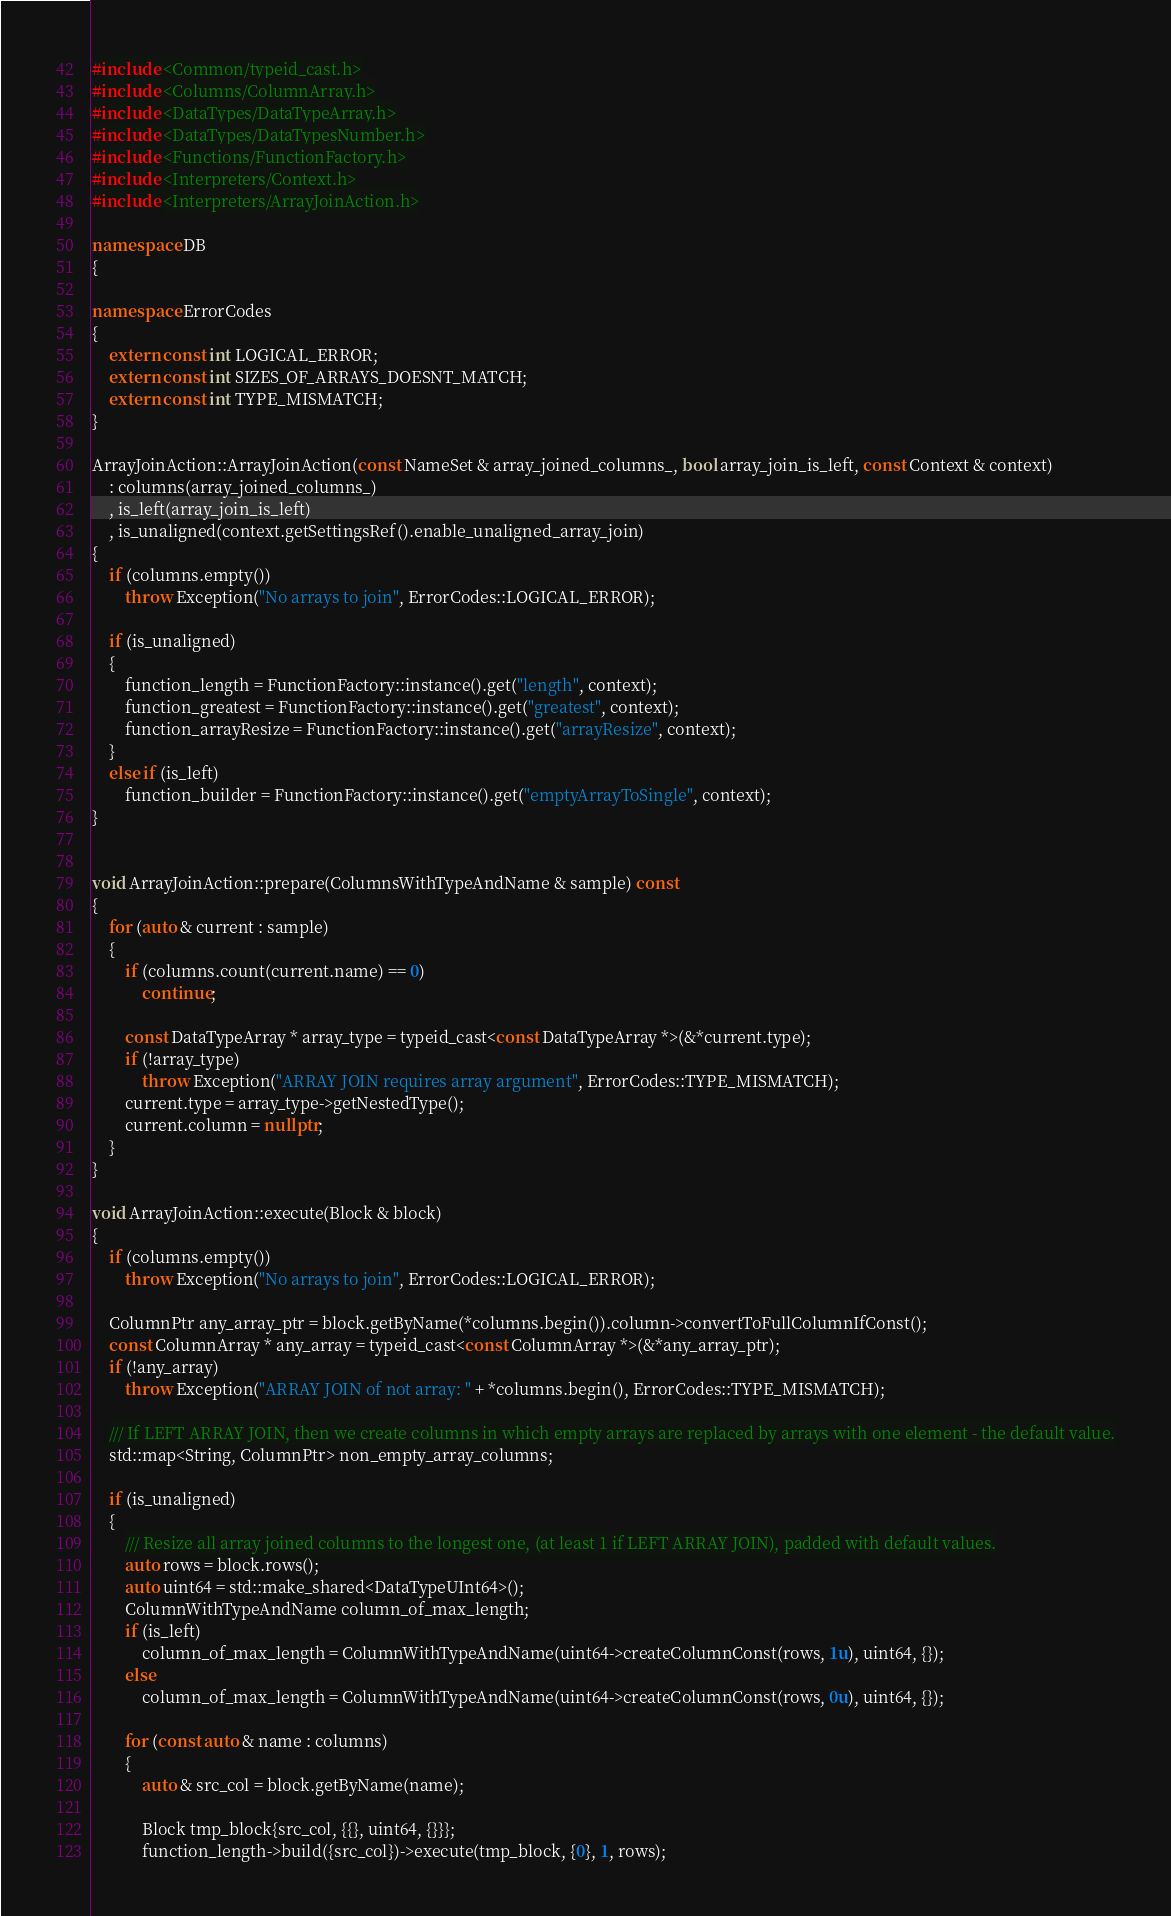Convert code to text. <code><loc_0><loc_0><loc_500><loc_500><_C++_>#include <Common/typeid_cast.h>
#include <Columns/ColumnArray.h>
#include <DataTypes/DataTypeArray.h>
#include <DataTypes/DataTypesNumber.h>
#include <Functions/FunctionFactory.h>
#include <Interpreters/Context.h>
#include <Interpreters/ArrayJoinAction.h>

namespace DB
{

namespace ErrorCodes
{
    extern const int LOGICAL_ERROR;
    extern const int SIZES_OF_ARRAYS_DOESNT_MATCH;
    extern const int TYPE_MISMATCH;
}

ArrayJoinAction::ArrayJoinAction(const NameSet & array_joined_columns_, bool array_join_is_left, const Context & context)
    : columns(array_joined_columns_)
    , is_left(array_join_is_left)
    , is_unaligned(context.getSettingsRef().enable_unaligned_array_join)
{
    if (columns.empty())
        throw Exception("No arrays to join", ErrorCodes::LOGICAL_ERROR);

    if (is_unaligned)
    {
        function_length = FunctionFactory::instance().get("length", context);
        function_greatest = FunctionFactory::instance().get("greatest", context);
        function_arrayResize = FunctionFactory::instance().get("arrayResize", context);
    }
    else if (is_left)
        function_builder = FunctionFactory::instance().get("emptyArrayToSingle", context);
}


void ArrayJoinAction::prepare(ColumnsWithTypeAndName & sample) const
{
    for (auto & current : sample)
    {
        if (columns.count(current.name) == 0)
            continue;

        const DataTypeArray * array_type = typeid_cast<const DataTypeArray *>(&*current.type);
        if (!array_type)
            throw Exception("ARRAY JOIN requires array argument", ErrorCodes::TYPE_MISMATCH);
        current.type = array_type->getNestedType();
        current.column = nullptr;
    }
}

void ArrayJoinAction::execute(Block & block)
{
    if (columns.empty())
        throw Exception("No arrays to join", ErrorCodes::LOGICAL_ERROR);

    ColumnPtr any_array_ptr = block.getByName(*columns.begin()).column->convertToFullColumnIfConst();
    const ColumnArray * any_array = typeid_cast<const ColumnArray *>(&*any_array_ptr);
    if (!any_array)
        throw Exception("ARRAY JOIN of not array: " + *columns.begin(), ErrorCodes::TYPE_MISMATCH);

    /// If LEFT ARRAY JOIN, then we create columns in which empty arrays are replaced by arrays with one element - the default value.
    std::map<String, ColumnPtr> non_empty_array_columns;

    if (is_unaligned)
    {
        /// Resize all array joined columns to the longest one, (at least 1 if LEFT ARRAY JOIN), padded with default values.
        auto rows = block.rows();
        auto uint64 = std::make_shared<DataTypeUInt64>();
        ColumnWithTypeAndName column_of_max_length;
        if (is_left)
            column_of_max_length = ColumnWithTypeAndName(uint64->createColumnConst(rows, 1u), uint64, {});
        else
            column_of_max_length = ColumnWithTypeAndName(uint64->createColumnConst(rows, 0u), uint64, {});

        for (const auto & name : columns)
        {
            auto & src_col = block.getByName(name);

            Block tmp_block{src_col, {{}, uint64, {}}};
            function_length->build({src_col})->execute(tmp_block, {0}, 1, rows);
</code> 